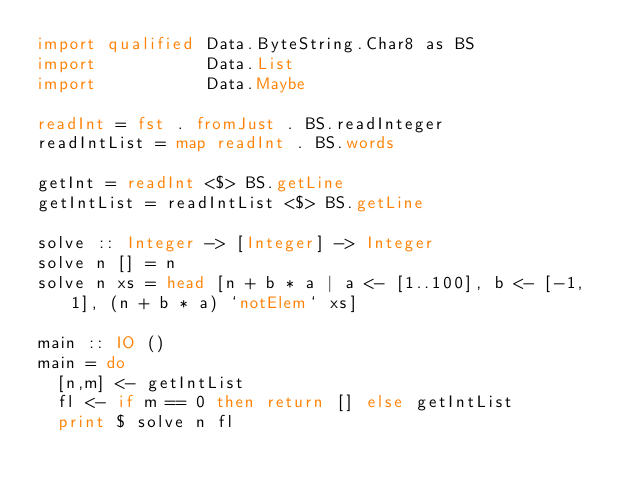<code> <loc_0><loc_0><loc_500><loc_500><_Haskell_>import qualified Data.ByteString.Char8 as BS
import           Data.List
import           Data.Maybe

readInt = fst . fromJust . BS.readInteger
readIntList = map readInt . BS.words

getInt = readInt <$> BS.getLine
getIntList = readIntList <$> BS.getLine

solve :: Integer -> [Integer] -> Integer
solve n [] = n
solve n xs = head [n + b * a | a <- [1..100], b <- [-1, 1], (n + b * a) `notElem` xs]

main :: IO ()
main = do
  [n,m] <- getIntList
  fl <- if m == 0 then return [] else getIntList
  print $ solve n fl
</code> 